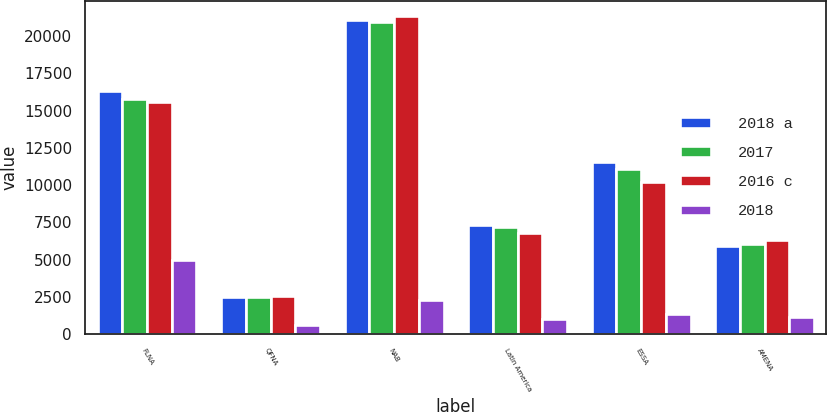Convert chart to OTSL. <chart><loc_0><loc_0><loc_500><loc_500><stacked_bar_chart><ecel><fcel>FLNA<fcel>QFNA<fcel>NAB<fcel>Latin America<fcel>ESSA<fcel>AMENA<nl><fcel>2018 a<fcel>16346<fcel>2465<fcel>21072<fcel>7354<fcel>11523<fcel>5901<nl><fcel>2017<fcel>15798<fcel>2503<fcel>20936<fcel>7208<fcel>11050<fcel>6030<nl><fcel>2016 c<fcel>15549<fcel>2564<fcel>21312<fcel>6820<fcel>10216<fcel>6338<nl><fcel>2018<fcel>5008<fcel>637<fcel>2276<fcel>1049<fcel>1364<fcel>1172<nl></chart> 